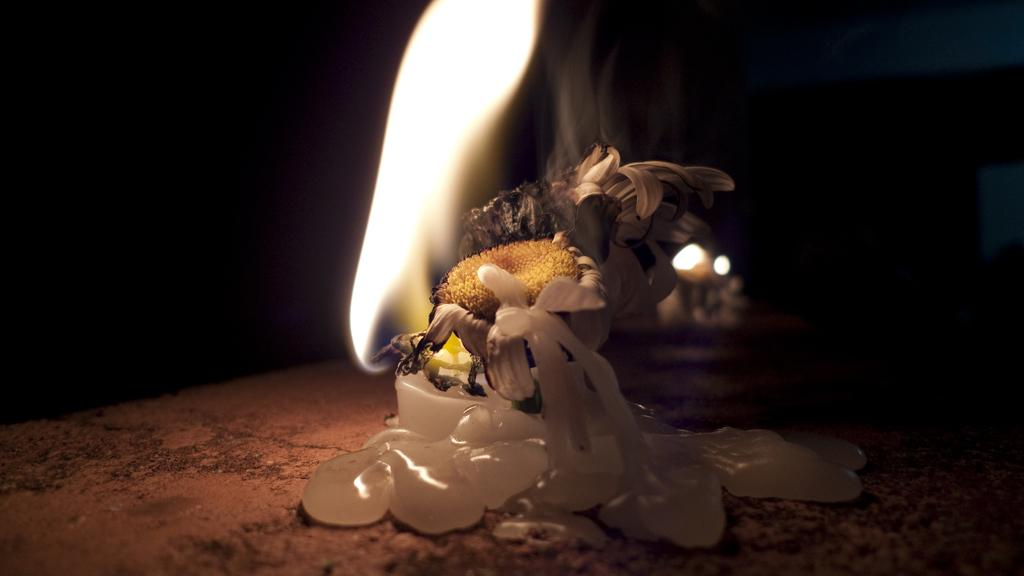What type of plant is in the image? There is a sunflower in the image. What other object can be seen in the image? There is a candle in the image. Where are the sunflower and candle located? The sunflower and candle are on a path. What is the color of the background in the image? The background of the image is dark. What type of conversation is the sunflower having with the candle in the image? The sunflower and candle are inanimate objects and cannot have a conversation. In which room of a house might this image be taken? The provided facts do not give any information about the room or location of the image. What type of winter clothing is visible in the image? There is no winter clothing, such as a mitten, present in the image. 